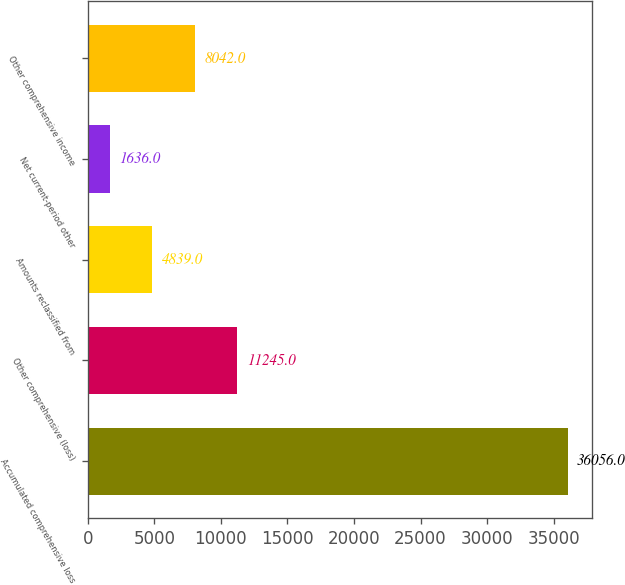Convert chart to OTSL. <chart><loc_0><loc_0><loc_500><loc_500><bar_chart><fcel>Accumulated comprehensive loss<fcel>Other comprehensive (loss)<fcel>Amounts reclassified from<fcel>Net current-period other<fcel>Other comprehensive income<nl><fcel>36056<fcel>11245<fcel>4839<fcel>1636<fcel>8042<nl></chart> 